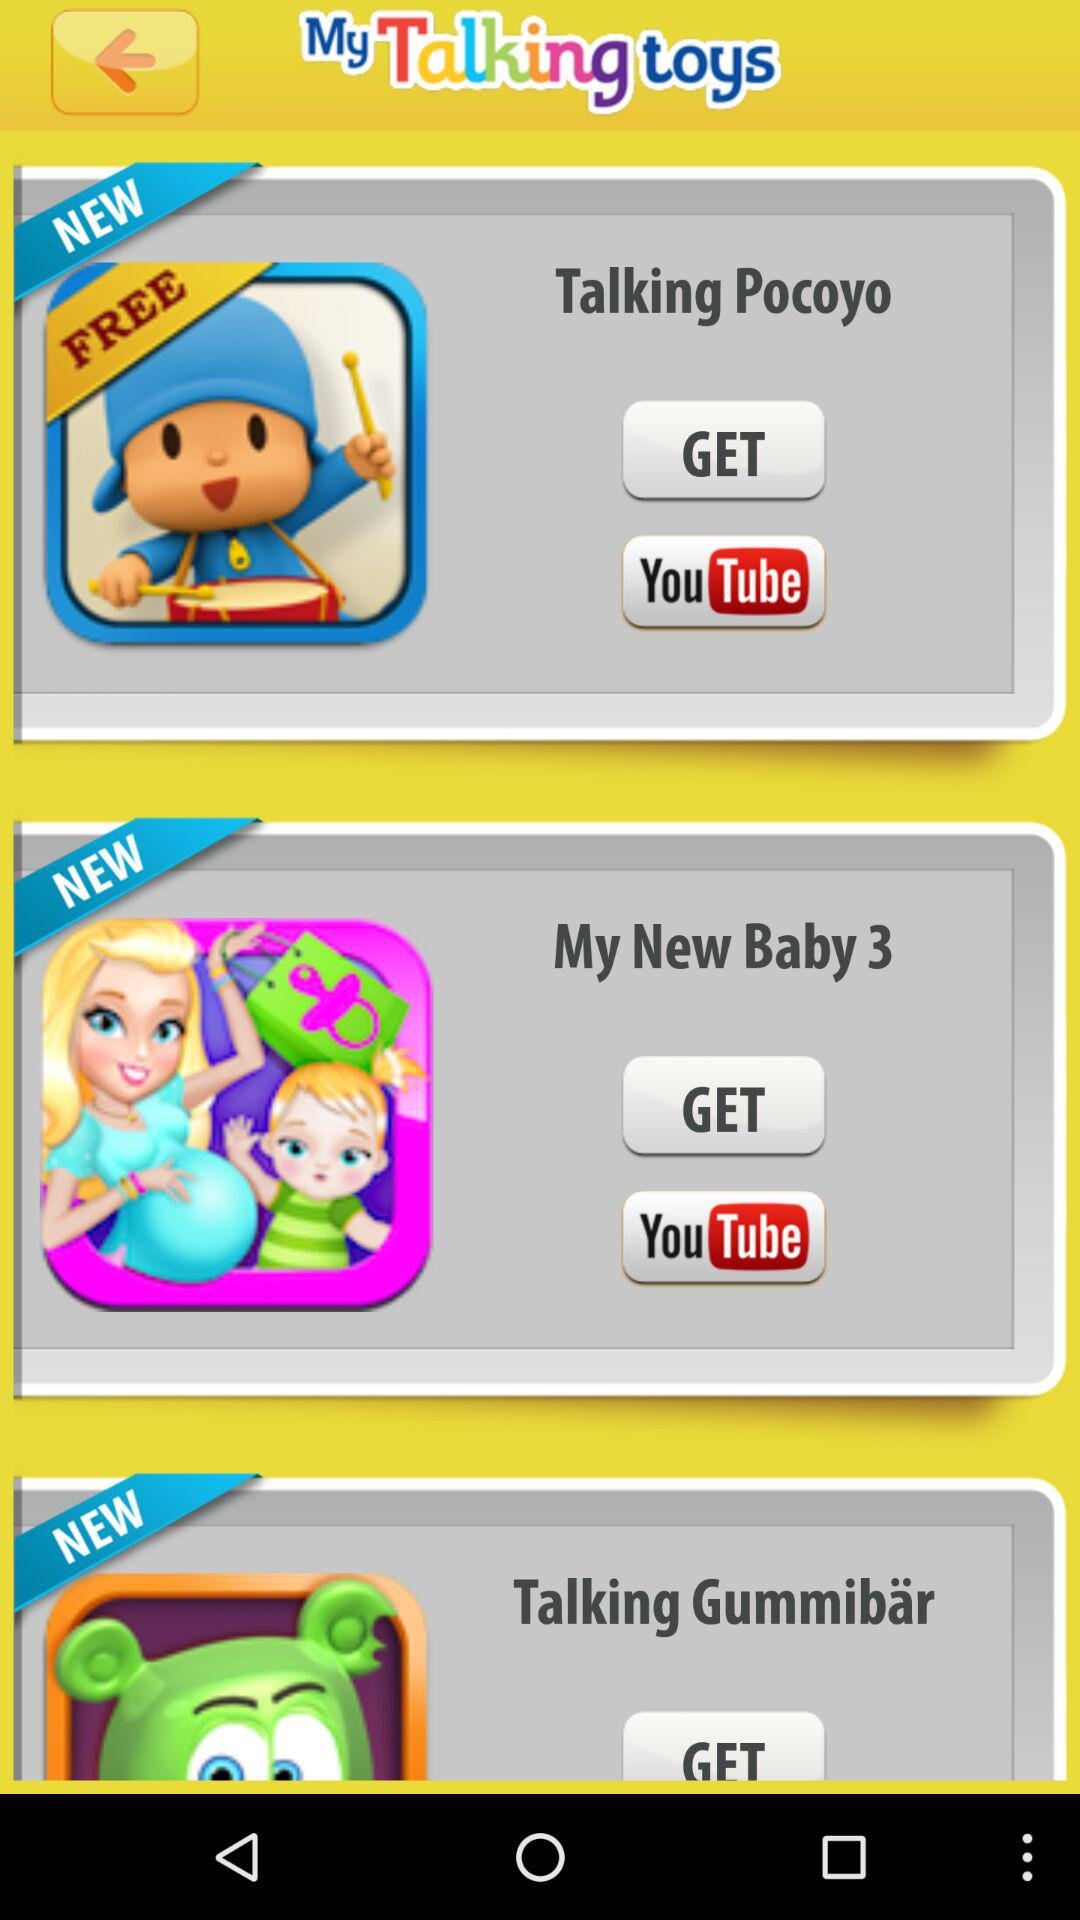Is Talking Pocoyo free or paid? The Talking Pocoyo is free. 